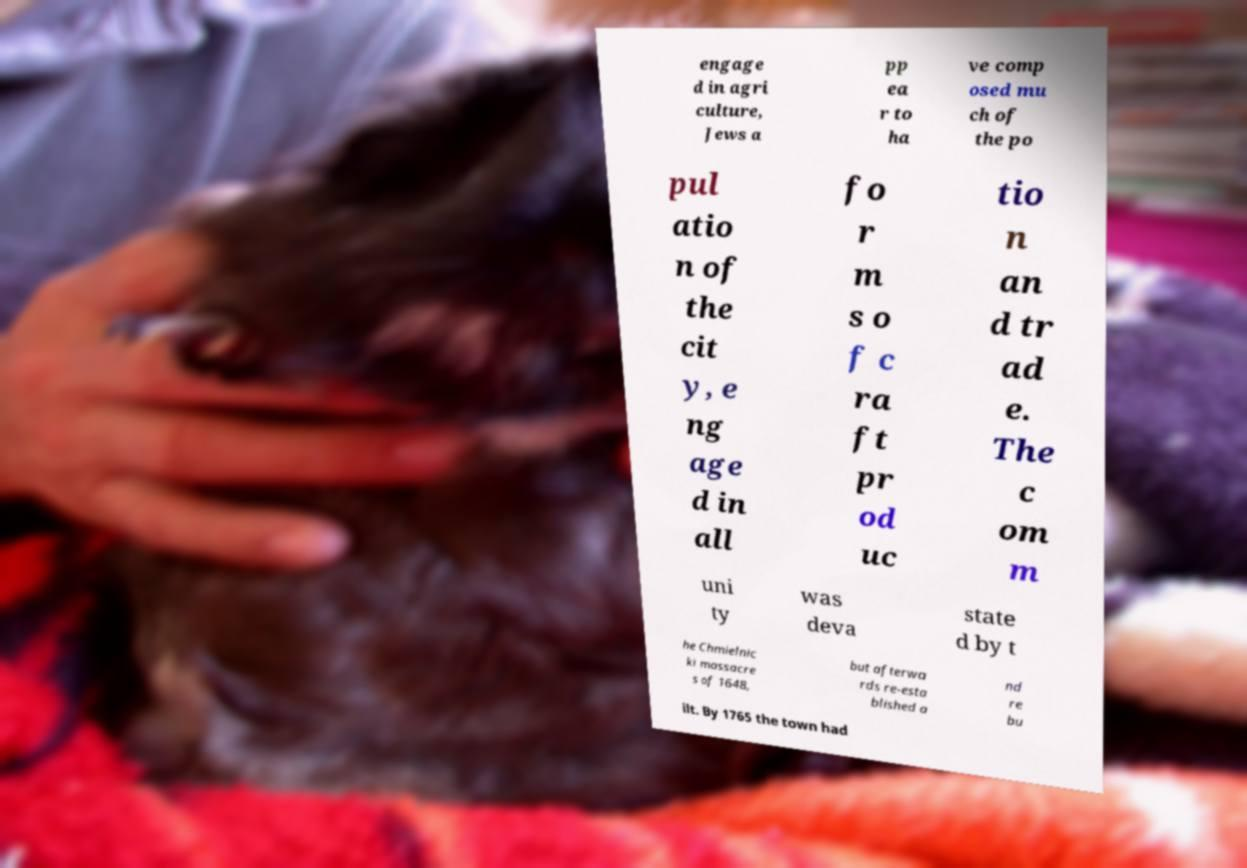Could you assist in decoding the text presented in this image and type it out clearly? engage d in agri culture, Jews a pp ea r to ha ve comp osed mu ch of the po pul atio n of the cit y, e ng age d in all fo r m s o f c ra ft pr od uc tio n an d tr ad e. The c om m uni ty was deva state d by t he Chmielnic ki massacre s of 1648, but afterwa rds re-esta blished a nd re bu ilt. By 1765 the town had 